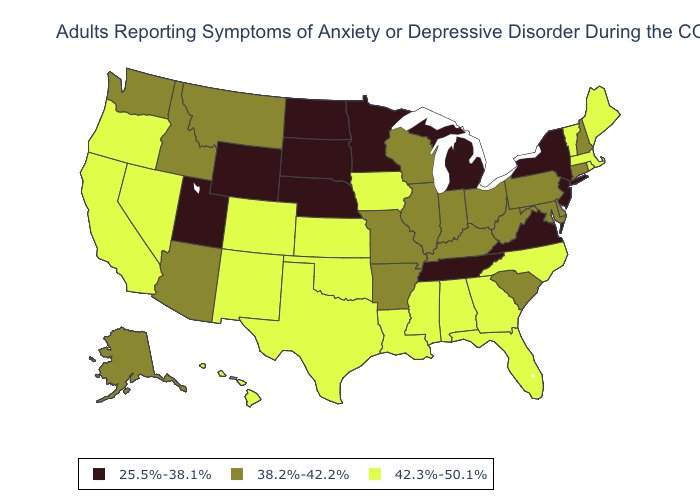Among the states that border Kansas , which have the highest value?
Concise answer only. Colorado, Oklahoma. Which states have the highest value in the USA?
Quick response, please. Alabama, California, Colorado, Florida, Georgia, Hawaii, Iowa, Kansas, Louisiana, Maine, Massachusetts, Mississippi, Nevada, New Mexico, North Carolina, Oklahoma, Oregon, Rhode Island, Texas, Vermont. Does the first symbol in the legend represent the smallest category?
Give a very brief answer. Yes. What is the value of Missouri?
Short answer required. 38.2%-42.2%. What is the lowest value in states that border Tennessee?
Answer briefly. 25.5%-38.1%. Among the states that border South Carolina , which have the lowest value?
Quick response, please. Georgia, North Carolina. Does Alaska have the lowest value in the USA?
Short answer required. No. What is the highest value in states that border New Mexico?
Keep it brief. 42.3%-50.1%. Does Minnesota have the highest value in the MidWest?
Keep it brief. No. What is the value of Washington?
Keep it brief. 38.2%-42.2%. Does South Dakota have the lowest value in the USA?
Concise answer only. Yes. Name the states that have a value in the range 25.5%-38.1%?
Concise answer only. Michigan, Minnesota, Nebraska, New Jersey, New York, North Dakota, South Dakota, Tennessee, Utah, Virginia, Wyoming. Does Washington have a higher value than Virginia?
Quick response, please. Yes. Does Alaska have the same value as Oklahoma?
Give a very brief answer. No. What is the lowest value in states that border Rhode Island?
Give a very brief answer. 38.2%-42.2%. 